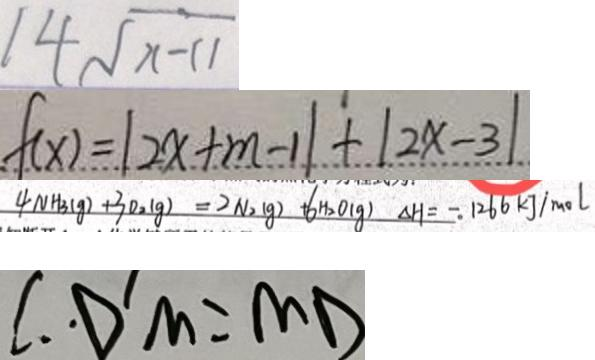Convert formula to latex. <formula><loc_0><loc_0><loc_500><loc_500>1 4 \sqrt { x - 1 1 } 
 f ( x ) = \vert 2 x + m - 1 \vert + \vert 2 x - 3 \vert 
 4 N H 3 ( g ) + 3 0 _ { 2 } ( g ) + = 2 N _ { 2 } ( g ) 6 H _ { 2 } O ( g ) \Delta H = - 1 2 6 6 k g / m o l 
 \therefore \cdot D ^ { \prime } M = M D</formula> 